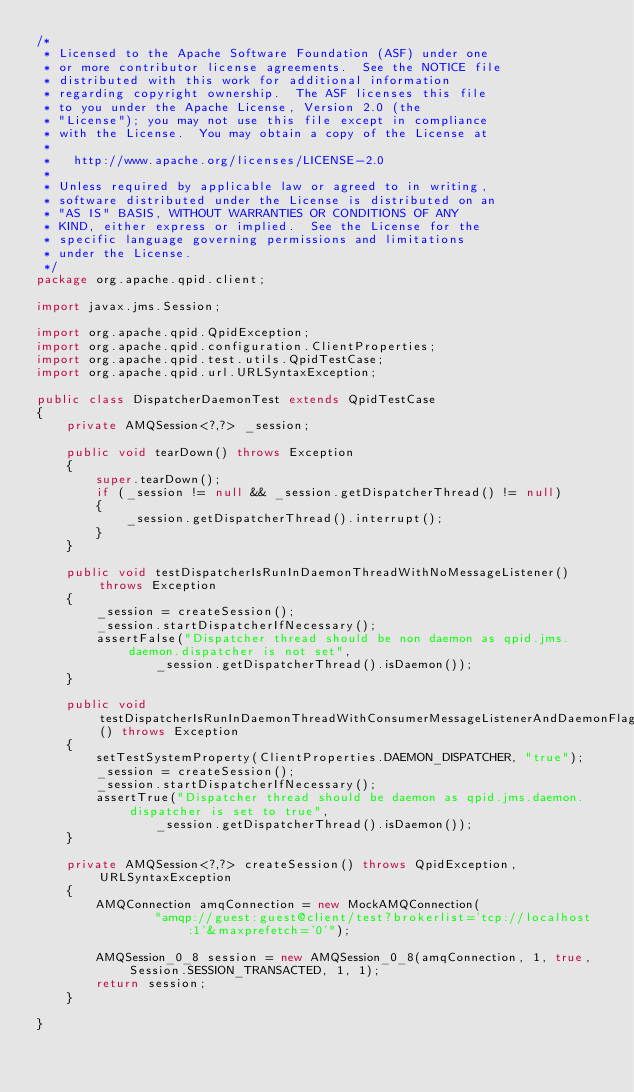Convert code to text. <code><loc_0><loc_0><loc_500><loc_500><_Java_>/*
 * Licensed to the Apache Software Foundation (ASF) under one
 * or more contributor license agreements.  See the NOTICE file
 * distributed with this work for additional information
 * regarding copyright ownership.  The ASF licenses this file
 * to you under the Apache License, Version 2.0 (the
 * "License"); you may not use this file except in compliance
 * with the License.  You may obtain a copy of the License at
 *
 *   http://www.apache.org/licenses/LICENSE-2.0
 *
 * Unless required by applicable law or agreed to in writing,
 * software distributed under the License is distributed on an
 * "AS IS" BASIS, WITHOUT WARRANTIES OR CONDITIONS OF ANY
 * KIND, either express or implied.  See the License for the
 * specific language governing permissions and limitations
 * under the License.
 */
package org.apache.qpid.client;

import javax.jms.Session;

import org.apache.qpid.QpidException;
import org.apache.qpid.configuration.ClientProperties;
import org.apache.qpid.test.utils.QpidTestCase;
import org.apache.qpid.url.URLSyntaxException;

public class DispatcherDaemonTest extends QpidTestCase
{
    private AMQSession<?,?> _session;

    public void tearDown() throws Exception
    {
        super.tearDown();
        if (_session != null && _session.getDispatcherThread() != null)
        {
            _session.getDispatcherThread().interrupt();
        }
    }

    public void testDispatcherIsRunInDaemonThreadWithNoMessageListener() throws Exception
    {
        _session = createSession();
        _session.startDispatcherIfNecessary();
        assertFalse("Dispatcher thread should be non daemon as qpid.jms.daemon.dispatcher is not set",
                _session.getDispatcherThread().isDaemon());
    }

    public void testDispatcherIsRunInDaemonThreadWithConsumerMessageListenerAndDaemonFlagOn() throws Exception
    {
        setTestSystemProperty(ClientProperties.DAEMON_DISPATCHER, "true");
        _session = createSession();
        _session.startDispatcherIfNecessary();
        assertTrue("Dispatcher thread should be daemon as qpid.jms.daemon.dispatcher is set to true",
                _session.getDispatcherThread().isDaemon());
    }

    private AMQSession<?,?> createSession() throws QpidException, URLSyntaxException
    {
        AMQConnection amqConnection = new MockAMQConnection(
                "amqp://guest:guest@client/test?brokerlist='tcp://localhost:1'&maxprefetch='0'");

        AMQSession_0_8 session = new AMQSession_0_8(amqConnection, 1, true, Session.SESSION_TRANSACTED, 1, 1);
        return session;
    }

}
</code> 